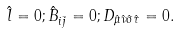<formula> <loc_0><loc_0><loc_500><loc_500>\hat { l } = 0 ; \hat { B } _ { i \bar { j } } = 0 ; D _ { \hat { \mu } \hat { \nu } \hat { \sigma } \hat { \tau } } = 0 .</formula> 